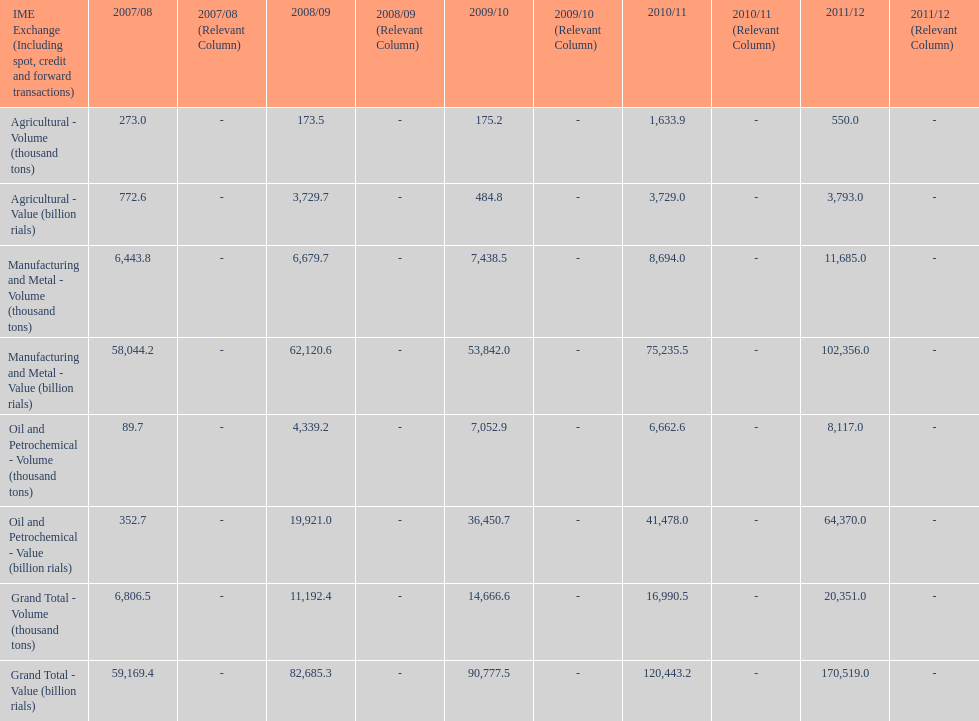Did 2010/11 or 2011/12 make more in grand total value? 2011/12. 